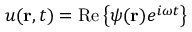Convert formula to latex. <formula><loc_0><loc_0><loc_500><loc_500>u ( r , t ) = R e \left \{ \psi ( r ) e ^ { i \omega t } \right \}</formula> 